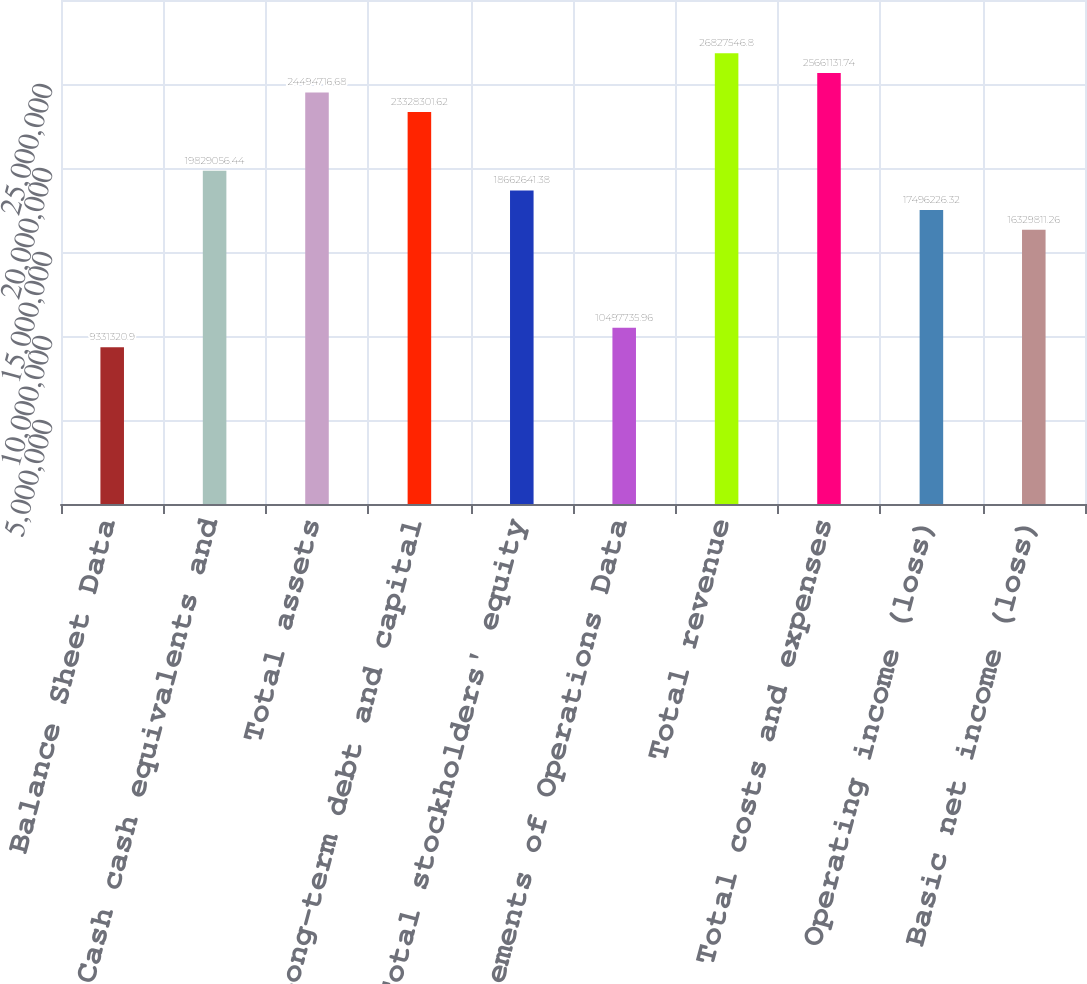Convert chart to OTSL. <chart><loc_0><loc_0><loc_500><loc_500><bar_chart><fcel>Balance Sheet Data<fcel>Cash cash equivalents and<fcel>Total assets<fcel>Long-term debt and capital<fcel>Total stockholders' equity<fcel>Statements of Operations Data<fcel>Total revenue<fcel>Total costs and expenses<fcel>Operating income (loss)<fcel>Basic net income (loss)<nl><fcel>9.33132e+06<fcel>1.98291e+07<fcel>2.44947e+07<fcel>2.33283e+07<fcel>1.86626e+07<fcel>1.04977e+07<fcel>2.68275e+07<fcel>2.56611e+07<fcel>1.74962e+07<fcel>1.63298e+07<nl></chart> 